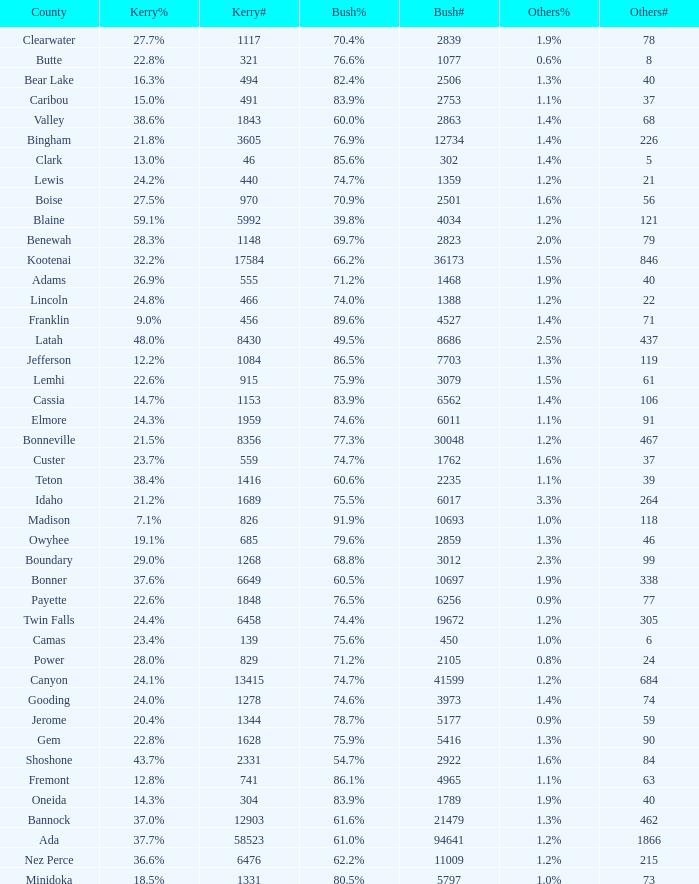What's percentage voted for Busg in the county where Kerry got 37.6%? 60.5%. 